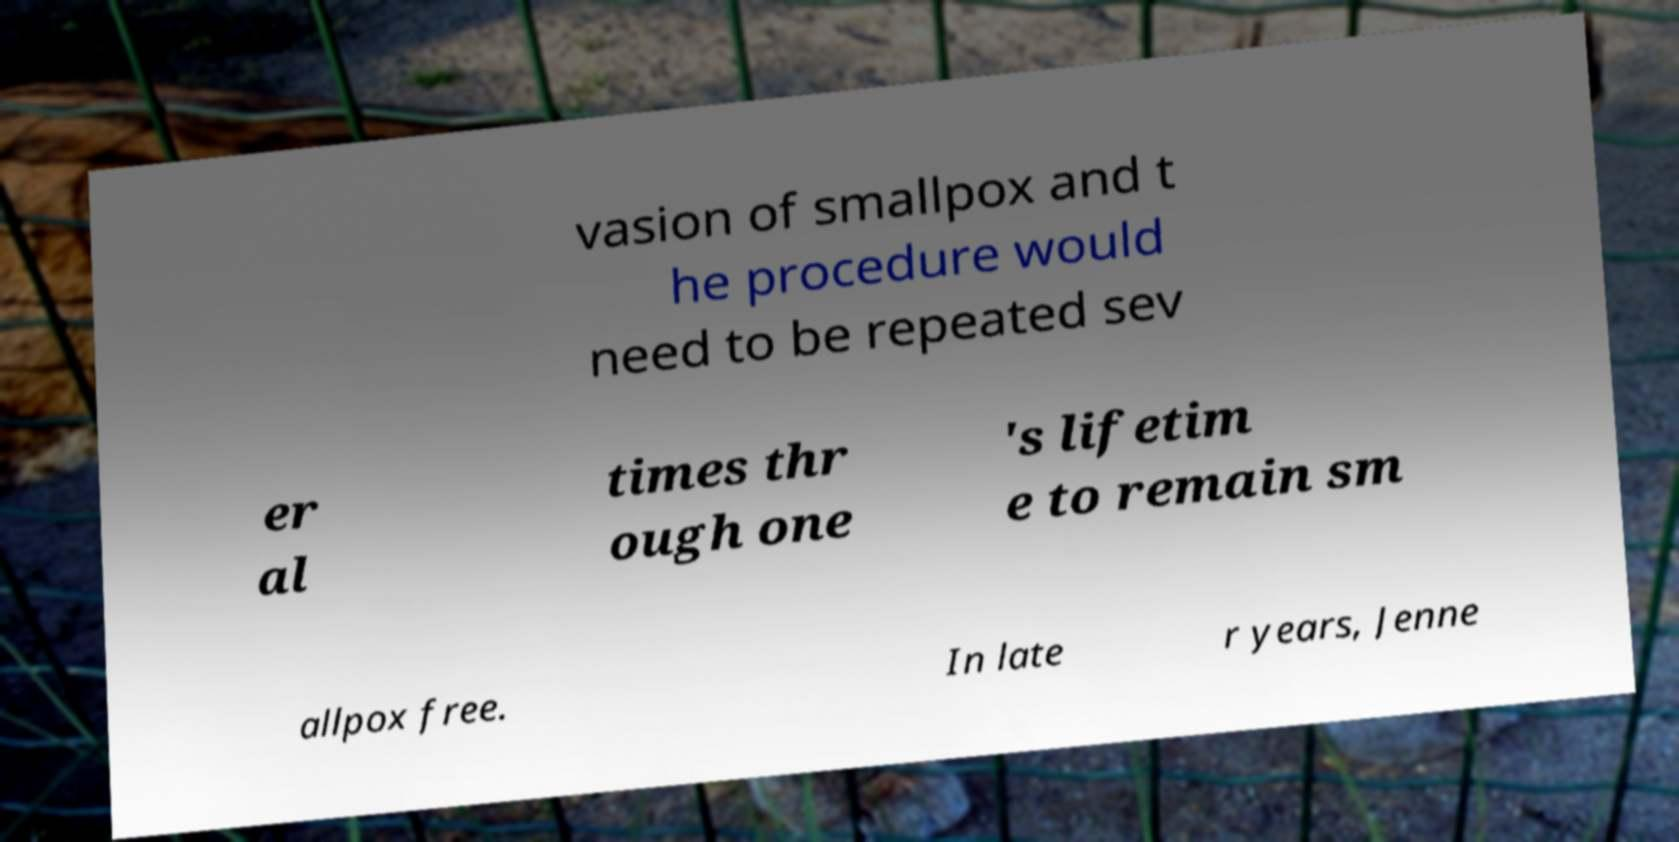I need the written content from this picture converted into text. Can you do that? vasion of smallpox and t he procedure would need to be repeated sev er al times thr ough one 's lifetim e to remain sm allpox free. In late r years, Jenne 